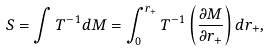<formula> <loc_0><loc_0><loc_500><loc_500>S = \int T ^ { - 1 } d M = \int ^ { r _ { + } } _ { 0 } T ^ { - 1 } \left ( \frac { \partial M } { \partial r _ { + } } \right ) d r _ { + } ,</formula> 